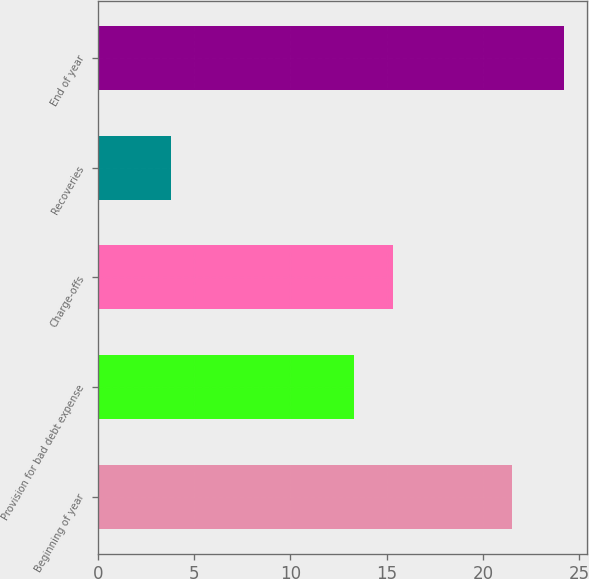Convert chart to OTSL. <chart><loc_0><loc_0><loc_500><loc_500><bar_chart><fcel>Beginning of year<fcel>Provision for bad debt expense<fcel>Charge-offs<fcel>Recoveries<fcel>End of year<nl><fcel>21.5<fcel>13.3<fcel>15.34<fcel>3.8<fcel>24.2<nl></chart> 